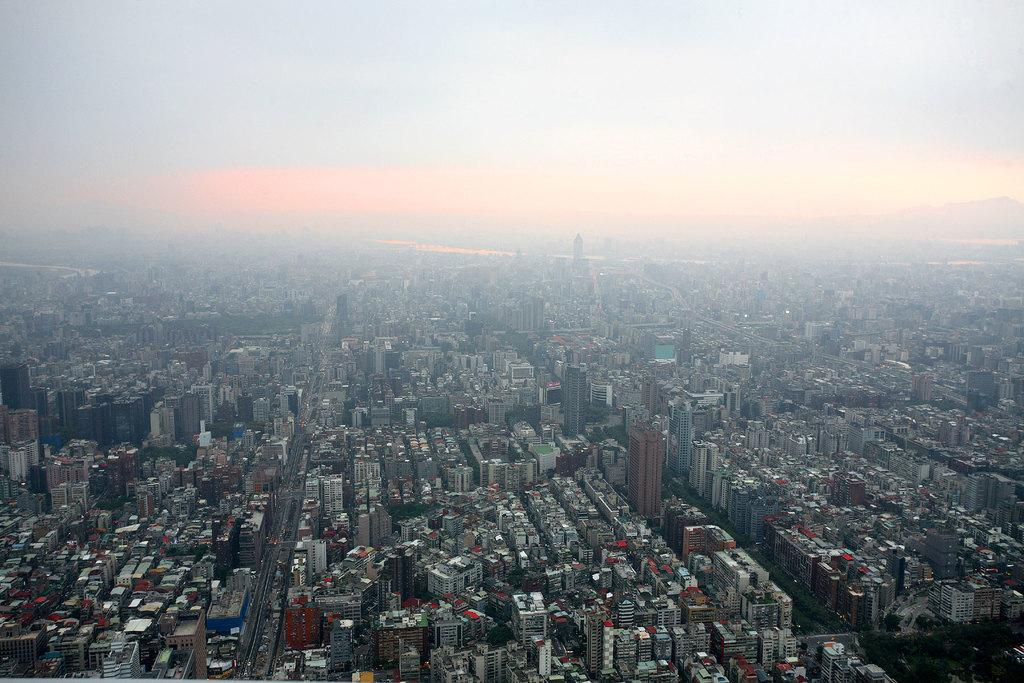What is the primary subject in the image? There are many buildings in the image. Can you describe the sky in the background of the image? The sky in the background is blue and white. How many rings can be seen on the buildings in the image? There are no rings visible on the buildings in the image. Is there any smoke coming from the buildings in the image? There is no indication of smoke coming from the buildings in the image. What type of vegetable is growing on the roofs of the buildings in the image? There are no vegetables, such as lettuce, present on the roofs of the buildings in the image. 